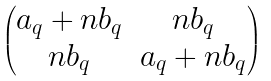Convert formula to latex. <formula><loc_0><loc_0><loc_500><loc_500>\begin{pmatrix} a _ { q } + n b _ { q } & n b _ { q } \\ n b _ { q } & a _ { q } + n b _ { q } \end{pmatrix}</formula> 